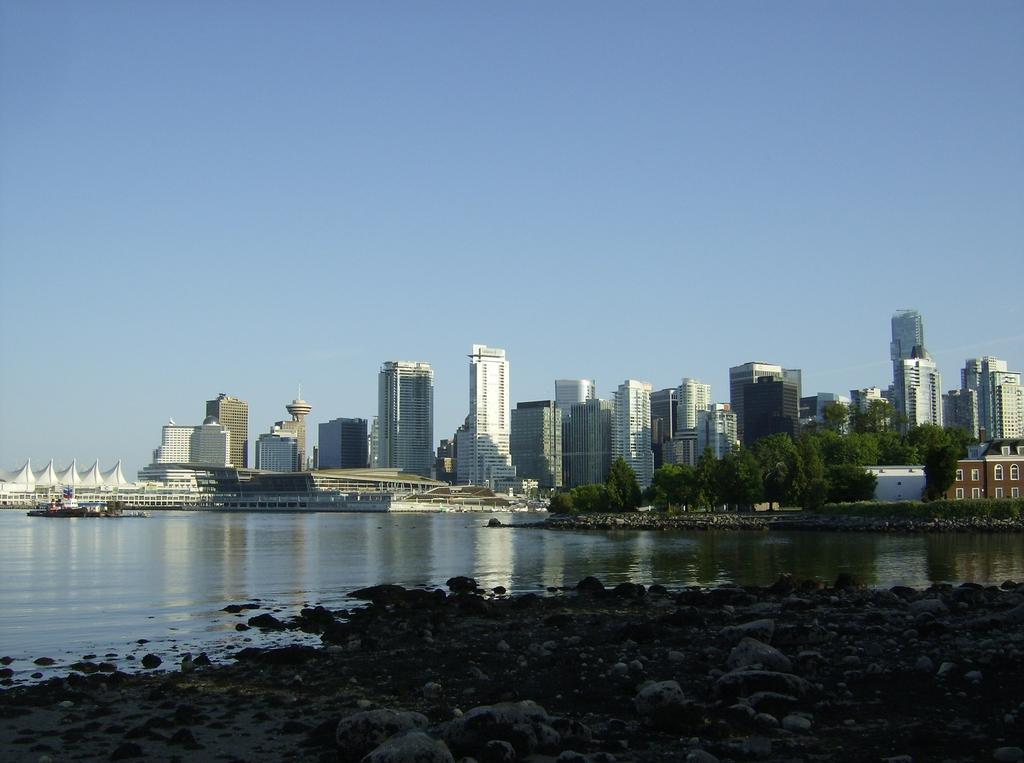What type of structures can be seen in the image? There are buildings in the image. What other natural elements are present in the image? There are trees in the image. What is visible at the top of the image? The sky is visible at the top of the image. What type of ground surface is at the bottom of the image? There are stones at the bottom of the image. What is the main feature in the center of the image? There is water in the center of the image. What type of skirt can be seen in the image? There is no skirt present in the image. What type of ocean is visible in the image? There is no ocean present in the image; it features water in the center, but not an ocean. 